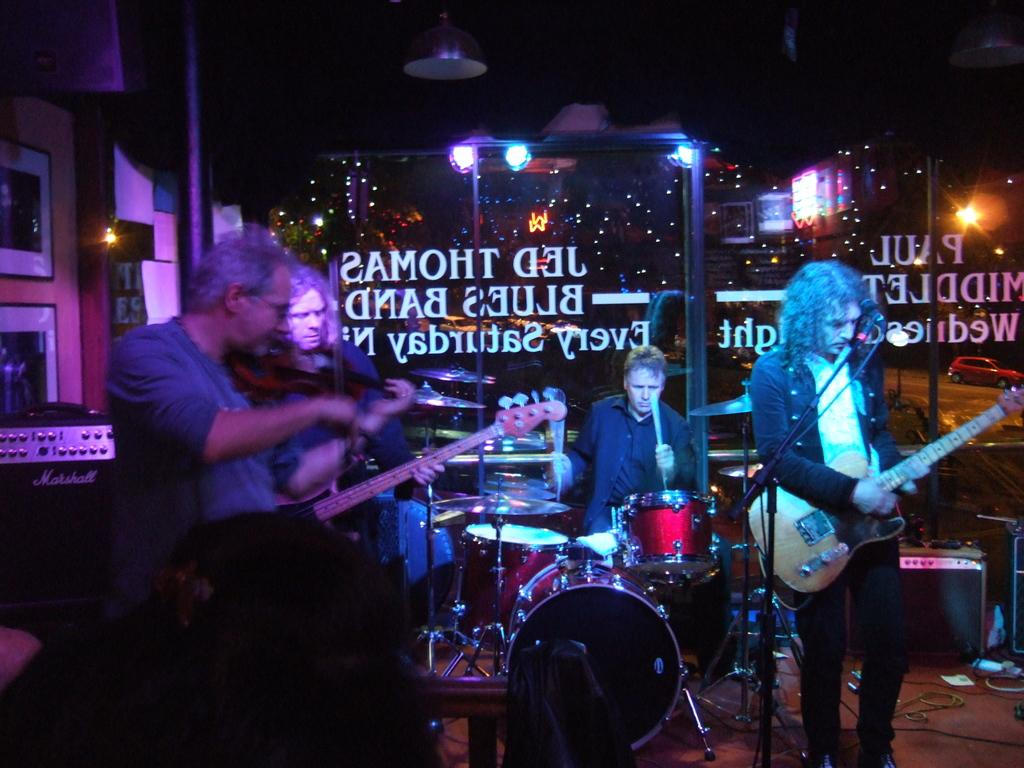What are the persons in the image doing? The persons in the image are playing musical instruments. What else can be seen in the image besides the persons playing instruments? There are lights visible in the image. What type of net is being used to catch the engine in the image? There is no net or engine present in the image; it features persons playing musical instruments and lights. 